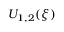<formula> <loc_0><loc_0><loc_500><loc_500>U _ { 1 , 2 } ( \xi )</formula> 